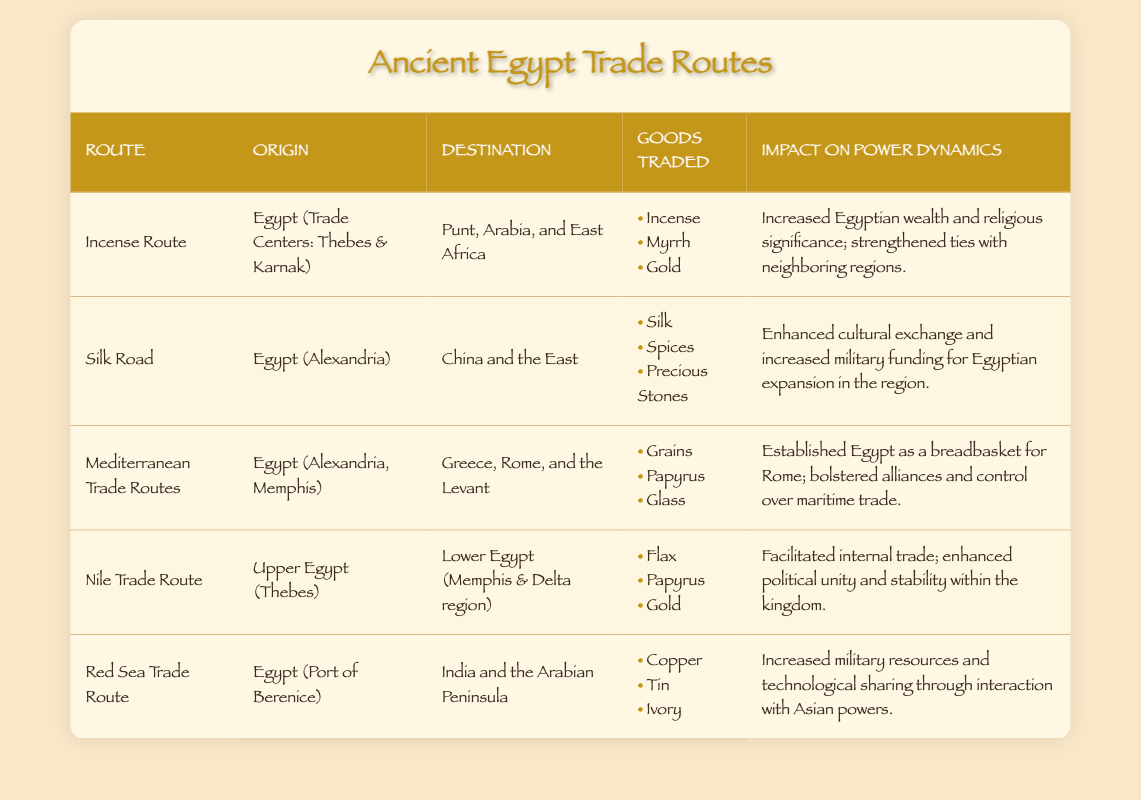What goods were traded on the Incense Route? The goods traded on the Incense Route, as listed in the table, are Incense, Myrrh, and Gold.
Answer: Incense, Myrrh, Gold What was the impact of the Mediterranean Trade Routes on Egypt's power dynamics? The table states that the Mediterranean Trade Routes established Egypt as a breadbasket for Rome, bolstered alliances, and controlled maritime trade.
Answer: Established Egypt as a breadbasket for Rome; bolstered alliances and control over maritime trade Which route had its origin in Upper Egypt and facilitated internal trade? The Nile Trade Route, as per the table, originates in Upper Egypt (Thebes) and is stated to facilitate internal trade and enhance political unity.
Answer: Nile Trade Route Did the Red Sea Trade Route increase military resources for Egypt? Yes, the table indicates that the Red Sea Trade Route increased military resources and enabled technological sharing through interactions with Asian powers.
Answer: Yes Which trade route involved trade with China and the East, and what goods were exchanged? The Silk Road involved trade with China and the East, and the goods traded included Silk, Spices, and Precious Stones, according to the table.
Answer: Silk Road; Silk, Spices, Precious Stones What trade route contributed to religious significance for Egypt? The Incense Route contributed to increased Egyptian wealth and religious significance, as highlighted in the table.
Answer: Incense Route Calculate the total number of unique destinations mentioned across all trade routes. The unique destinations from each route listed are: Punt, Arabia, East Africa, China, Greece, Rome, the Levant, Lower Egypt, India, and the Arabian Peninsula. This totals to 10 unique destinations.
Answer: 10 What is the significance of Egypt's position in the Mediterranean Trade Routes compared to the Red Sea Trade Route in terms of regional influence? The Mediterranean Trade Routes established Egypt as a vital breadbasket and enhanced alliances, while the Red Sea Trade Route increased military resources. This indicates that the Mediterranean Trade Routes had a broader influence on regional power dynamics by establishing economic strength.
Answer: Mediterranean Trade Routes had broader influence Did the Silk Road contribute to cultural exchange for Egypt? Yes, the table indicates that the Silk Road enhanced cultural exchange and increased military funding for Egyptian expansion.
Answer: Yes 